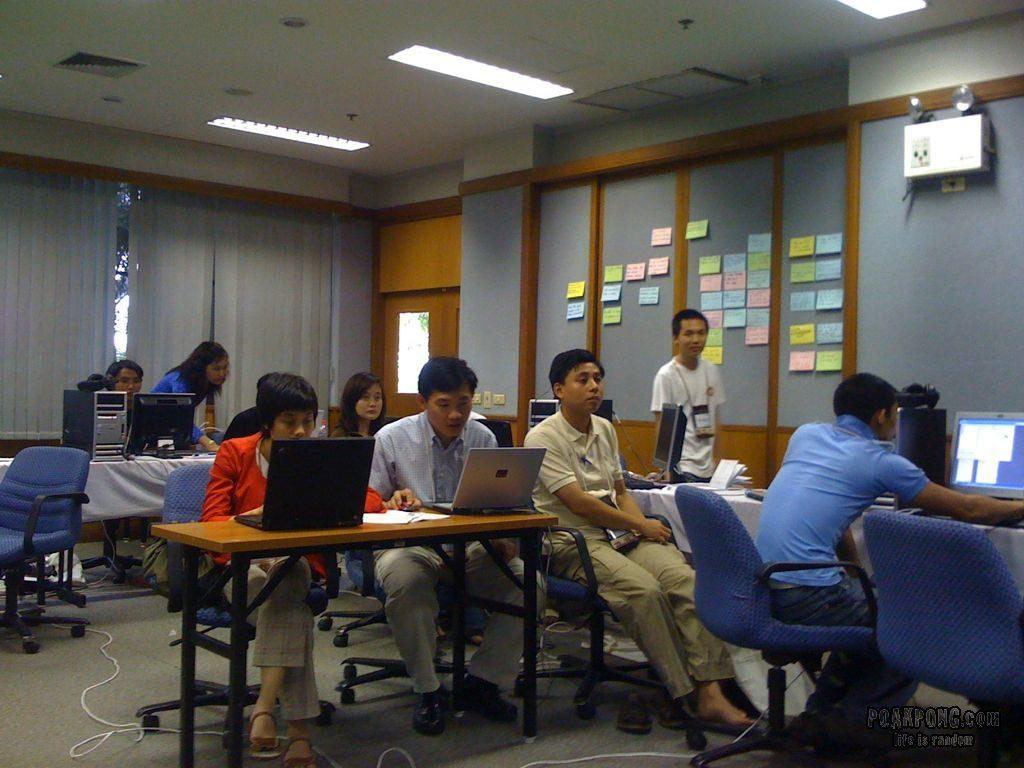How would you summarize this image in a sentence or two? In this picture there is a man sitting over he has a monitor in front of him, there is a central processing unit kept on the table here and there is a woman standing beside him and this row there are two people sitting there operating the laptop and there are some papers over here and on the left this person sitting on the chair, he is also operating a computer and in the backdrop there is a person standing, there is a wall over here with some papers posted on it. 